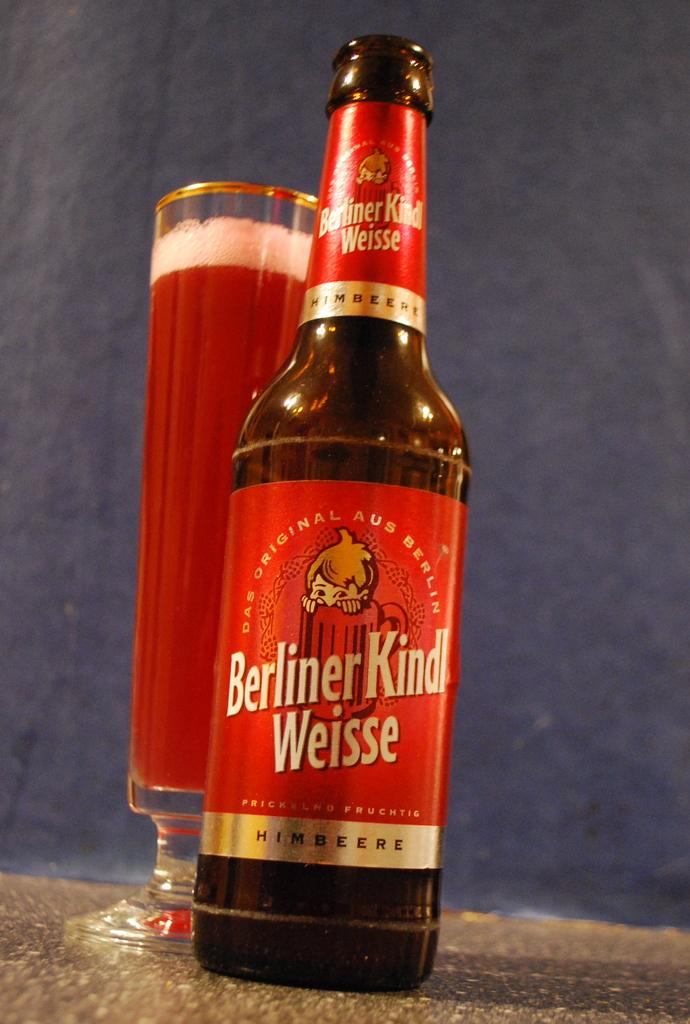What type of container is present in the image? There is a glass bottle in the image. What else can be seen in the image that is related to beverages? There is a glass of drink in the image. How are the glass bottle and the glass of drink positioned in relation to each other? The glass of drink is beside the glass bottle. What is the tendency of the rabbit in the image? There is no rabbit present in the image. What is the yoke used for in the image? There is no yoke present in the image. 